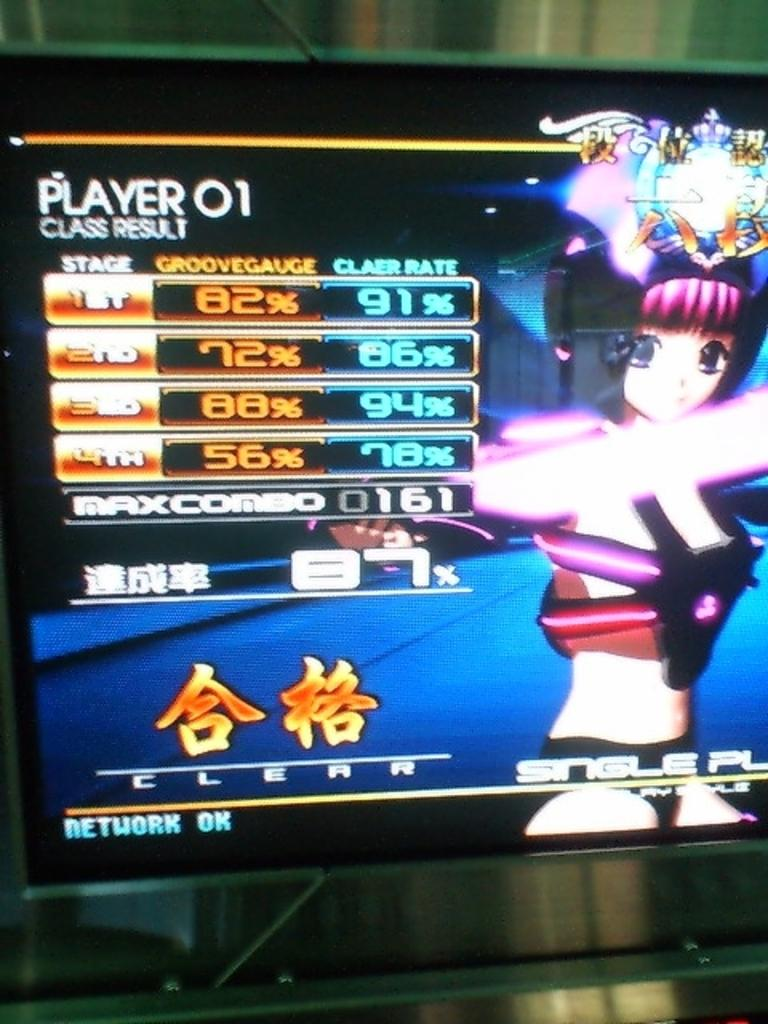What is the main object in the image? There is a screen in the image. What can be seen on the screen? A person is visible on the screen, and there is text or writing on the screen. Can you describe the background of the image? The background of the image is blurred. What type of blade is being used to sing a song in the image? There is no blade or singing in the image; it only features a screen with a person and text or writing. 